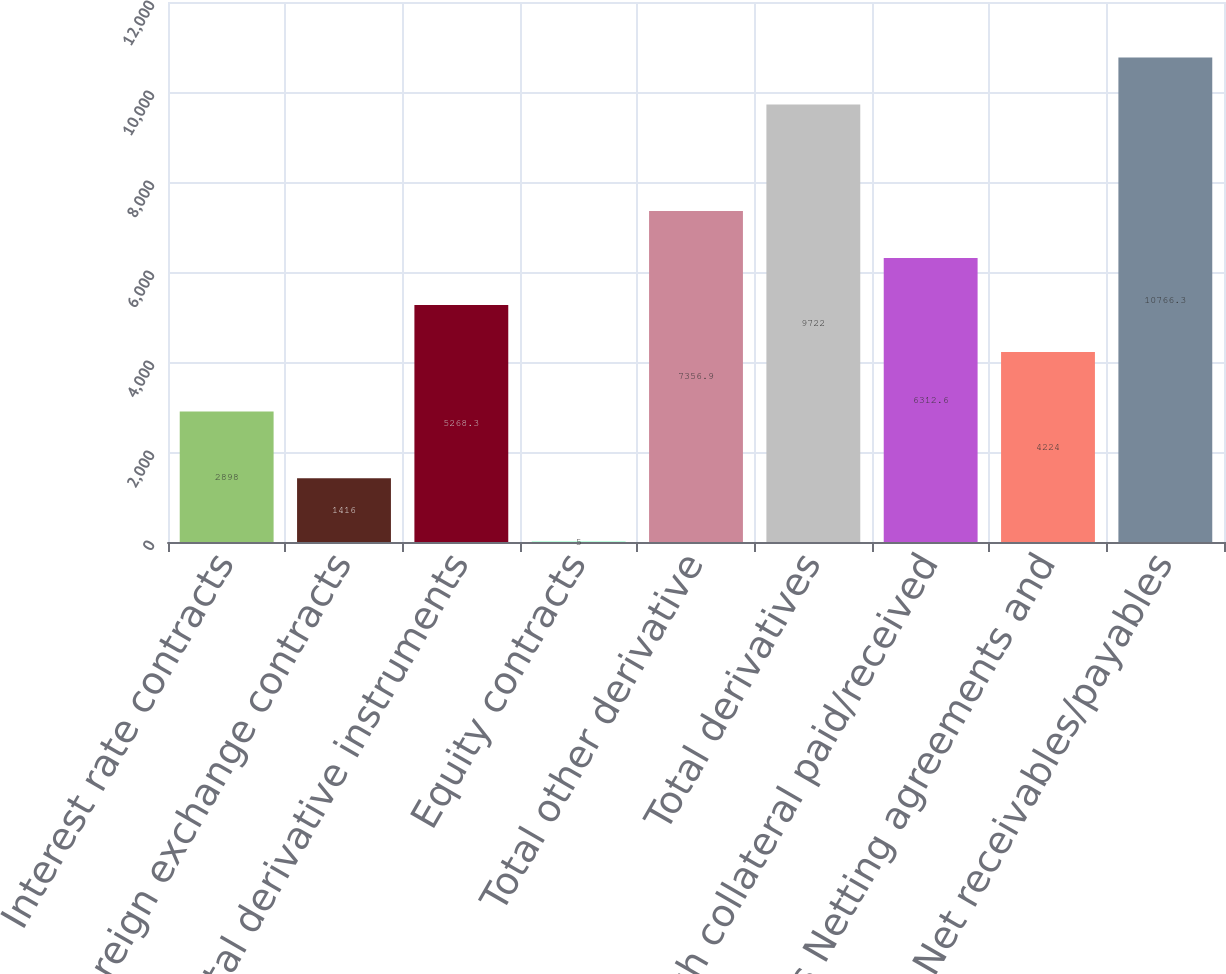<chart> <loc_0><loc_0><loc_500><loc_500><bar_chart><fcel>Interest rate contracts<fcel>Foreign exchange contracts<fcel>Total derivative instruments<fcel>Equity contracts<fcel>Total other derivative<fcel>Total derivatives<fcel>Cash collateral paid/received<fcel>Less Netting agreements and<fcel>Net receivables/payables<nl><fcel>2898<fcel>1416<fcel>5268.3<fcel>5<fcel>7356.9<fcel>9722<fcel>6312.6<fcel>4224<fcel>10766.3<nl></chart> 